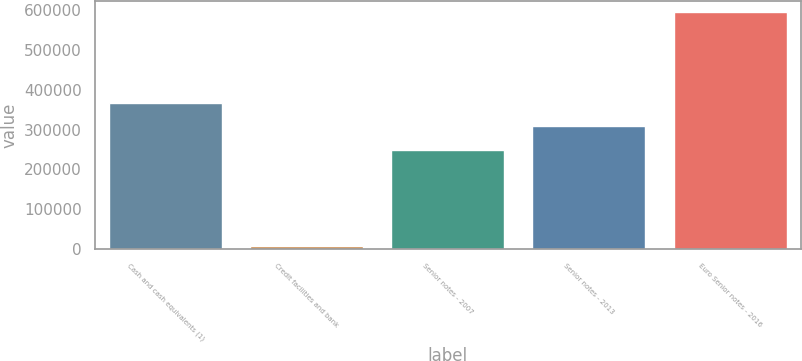Convert chart to OTSL. <chart><loc_0><loc_0><loc_500><loc_500><bar_chart><fcel>Cash and cash equivalents (1)<fcel>Credit facilities and bank<fcel>Senior notes - 2007<fcel>Senior notes - 2013<fcel>Euro Senior notes - 2016<nl><fcel>368046<fcel>7993<fcel>250000<fcel>308641<fcel>594400<nl></chart> 